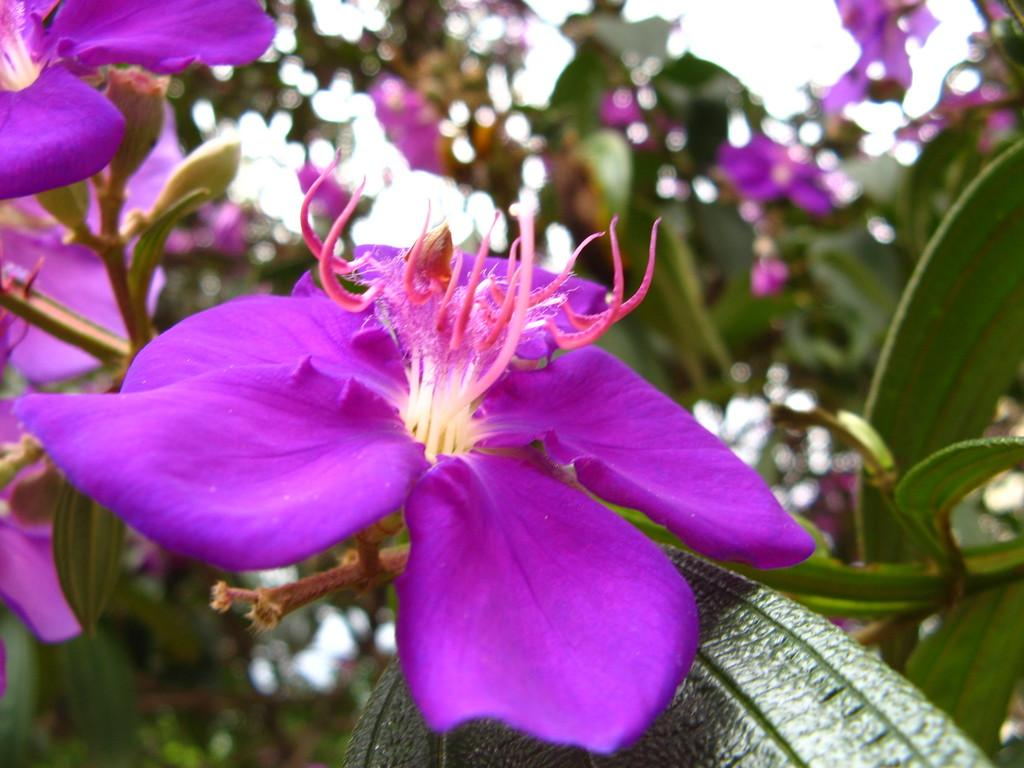What type of flowers are present in the image? There are violet color flowers in the image. Can you describe the background of the image? The background of the image is blurred. How many lizards can be seen crawling among the flowers in the image? There are no lizards present in the image; it only features flowers. Are there any dolls visible among the flowers in the image? There are no dolls present in the image; it only features flowers. 